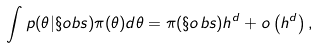<formula> <loc_0><loc_0><loc_500><loc_500>\int p ( \theta | \S o b s ) \pi ( \theta ) d \theta = \pi ( \S o b s ) h ^ { d } + o \left ( h ^ { d } \right ) ,</formula> 